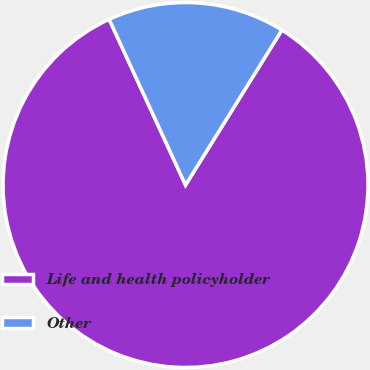Convert chart. <chart><loc_0><loc_0><loc_500><loc_500><pie_chart><fcel>Life and health policyholder<fcel>Other<nl><fcel>84.27%<fcel>15.73%<nl></chart> 